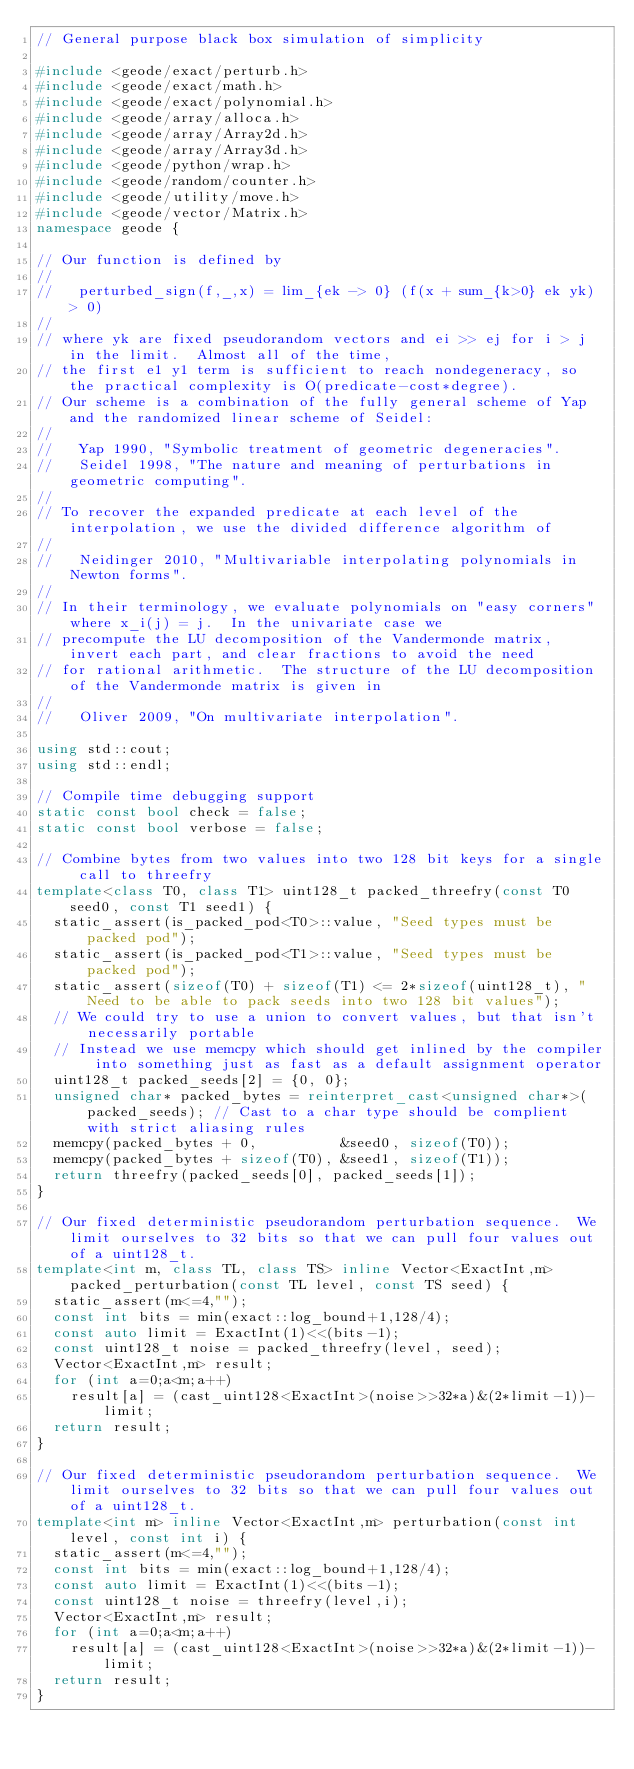<code> <loc_0><loc_0><loc_500><loc_500><_C++_>// General purpose black box simulation of simplicity

#include <geode/exact/perturb.h>
#include <geode/exact/math.h>
#include <geode/exact/polynomial.h>
#include <geode/array/alloca.h>
#include <geode/array/Array2d.h>
#include <geode/array/Array3d.h>
#include <geode/python/wrap.h>
#include <geode/random/counter.h>
#include <geode/utility/move.h>
#include <geode/vector/Matrix.h>
namespace geode {

// Our function is defined by
//
//   perturbed_sign(f,_,x) = lim_{ek -> 0} (f(x + sum_{k>0} ek yk) > 0)
//
// where yk are fixed pseudorandom vectors and ei >> ej for i > j in the limit.  Almost all of the time,
// the first e1 y1 term is sufficient to reach nondegeneracy, so the practical complexity is O(predicate-cost*degree).
// Our scheme is a combination of the fully general scheme of Yap and the randomized linear scheme of Seidel:
//
//   Yap 1990, "Symbolic treatment of geometric degeneracies".
//   Seidel 1998, "The nature and meaning of perturbations in geometric computing".
//
// To recover the expanded predicate at each level of the interpolation, we use the divided difference algorithm of
//
//   Neidinger 2010, "Multivariable interpolating polynomials in Newton forms".
//
// In their terminology, we evaluate polynomials on "easy corners" where x_i(j) = j.  In the univariate case we
// precompute the LU decomposition of the Vandermonde matrix, invert each part, and clear fractions to avoid the need
// for rational arithmetic.  The structure of the LU decomposition of the Vandermonde matrix is given in
//
//   Oliver 2009, "On multivariate interpolation".

using std::cout;
using std::endl;

// Compile time debugging support
static const bool check = false;
static const bool verbose = false;

// Combine bytes from two values into two 128 bit keys for a single call to threefry
template<class T0, class T1> uint128_t packed_threefry(const T0 seed0, const T1 seed1) {
  static_assert(is_packed_pod<T0>::value, "Seed types must be packed pod");
  static_assert(is_packed_pod<T1>::value, "Seed types must be packed pod");
  static_assert(sizeof(T0) + sizeof(T1) <= 2*sizeof(uint128_t), "Need to be able to pack seeds into two 128 bit values");
  // We could try to use a union to convert values, but that isn't necessarily portable
  // Instead we use memcpy which should get inlined by the compiler into something just as fast as a default assignment operator
  uint128_t packed_seeds[2] = {0, 0};
  unsigned char* packed_bytes = reinterpret_cast<unsigned char*>(packed_seeds); // Cast to a char type should be complient with strict aliasing rules
  memcpy(packed_bytes + 0,          &seed0, sizeof(T0));
  memcpy(packed_bytes + sizeof(T0), &seed1, sizeof(T1));
  return threefry(packed_seeds[0], packed_seeds[1]);
}

// Our fixed deterministic pseudorandom perturbation sequence.  We limit ourselves to 32 bits so that we can pull four values out of a uint128_t.
template<int m, class TL, class TS> inline Vector<ExactInt,m> packed_perturbation(const TL level, const TS seed) {
  static_assert(m<=4,"");
  const int bits = min(exact::log_bound+1,128/4);
  const auto limit = ExactInt(1)<<(bits-1);
  const uint128_t noise = packed_threefry(level, seed);
  Vector<ExactInt,m> result;
  for (int a=0;a<m;a++)
    result[a] = (cast_uint128<ExactInt>(noise>>32*a)&(2*limit-1))-limit;
  return result;
}

// Our fixed deterministic pseudorandom perturbation sequence.  We limit ourselves to 32 bits so that we can pull four values out of a uint128_t.
template<int m> inline Vector<ExactInt,m> perturbation(const int level, const int i) {
  static_assert(m<=4,"");
  const int bits = min(exact::log_bound+1,128/4);
  const auto limit = ExactInt(1)<<(bits-1);
  const uint128_t noise = threefry(level,i);
  Vector<ExactInt,m> result;
  for (int a=0;a<m;a++)
    result[a] = (cast_uint128<ExactInt>(noise>>32*a)&(2*limit-1))-limit;
  return result;
}</code> 